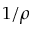Convert formula to latex. <formula><loc_0><loc_0><loc_500><loc_500>1 / \rho</formula> 